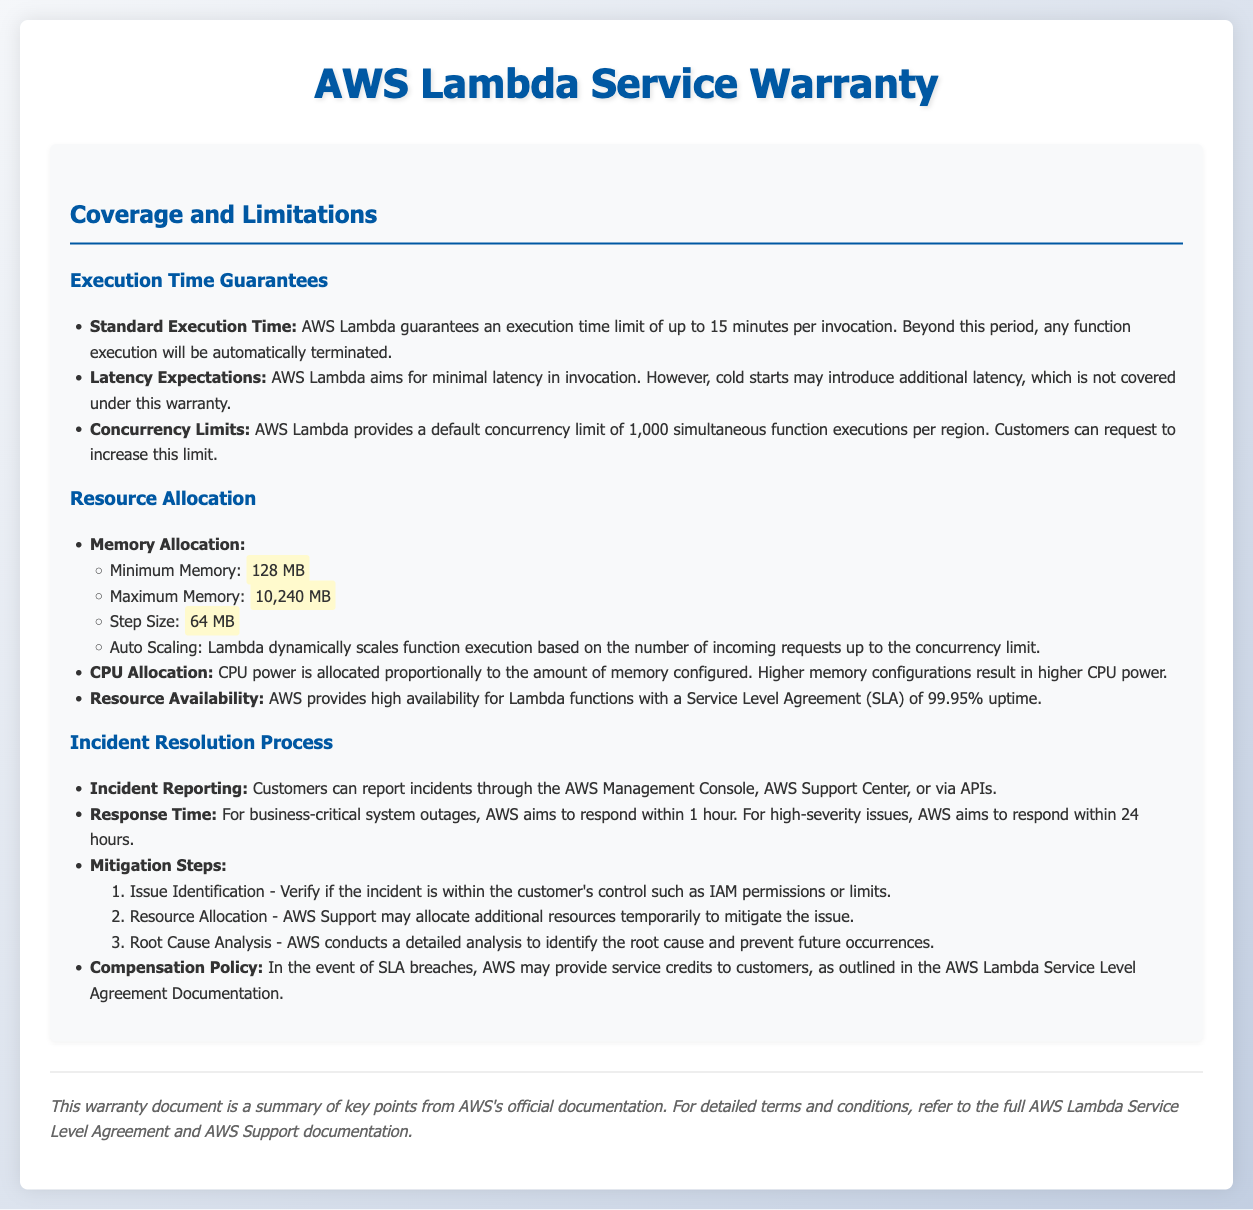What is the maximum execution time for AWS Lambda? The maximum execution time guaranteed by AWS Lambda is specified as 15 minutes per invocation.
Answer: 15 minutes What is the default concurrency limit for AWS Lambda functions per region? The document states that the default concurrency limit is 1,000 simultaneous function executions per region.
Answer: 1,000 What is the minimum memory allocation for AWS Lambda? The minimum memory allocation mentioned in the document is 128 MB.
Answer: 128 MB What is the SLA uptime percentage for AWS Lambda? The service level agreement (SLA) for AWS Lambda provides a stated uptime of 99.95%.
Answer: 99.95% What is the response time goal for business-critical system outages? AWS aims to respond within 1 hour for business-critical system outages.
Answer: 1 hour What are the mitigation steps listed in the incident resolution process? The document outlines issue identification, resource allocation, and root cause analysis as mitigation steps.
Answer: Issue identification, resource allocation, root cause analysis What is the compensation policy for SLA breaches? AWS may provide service credits to customers in the event of SLA breaches.
Answer: Service credits Which API can be used to report incidents? The document mentions that incidents can be reported via the AWS Support Center or APIs.
Answer: AWS Support Center or APIs 